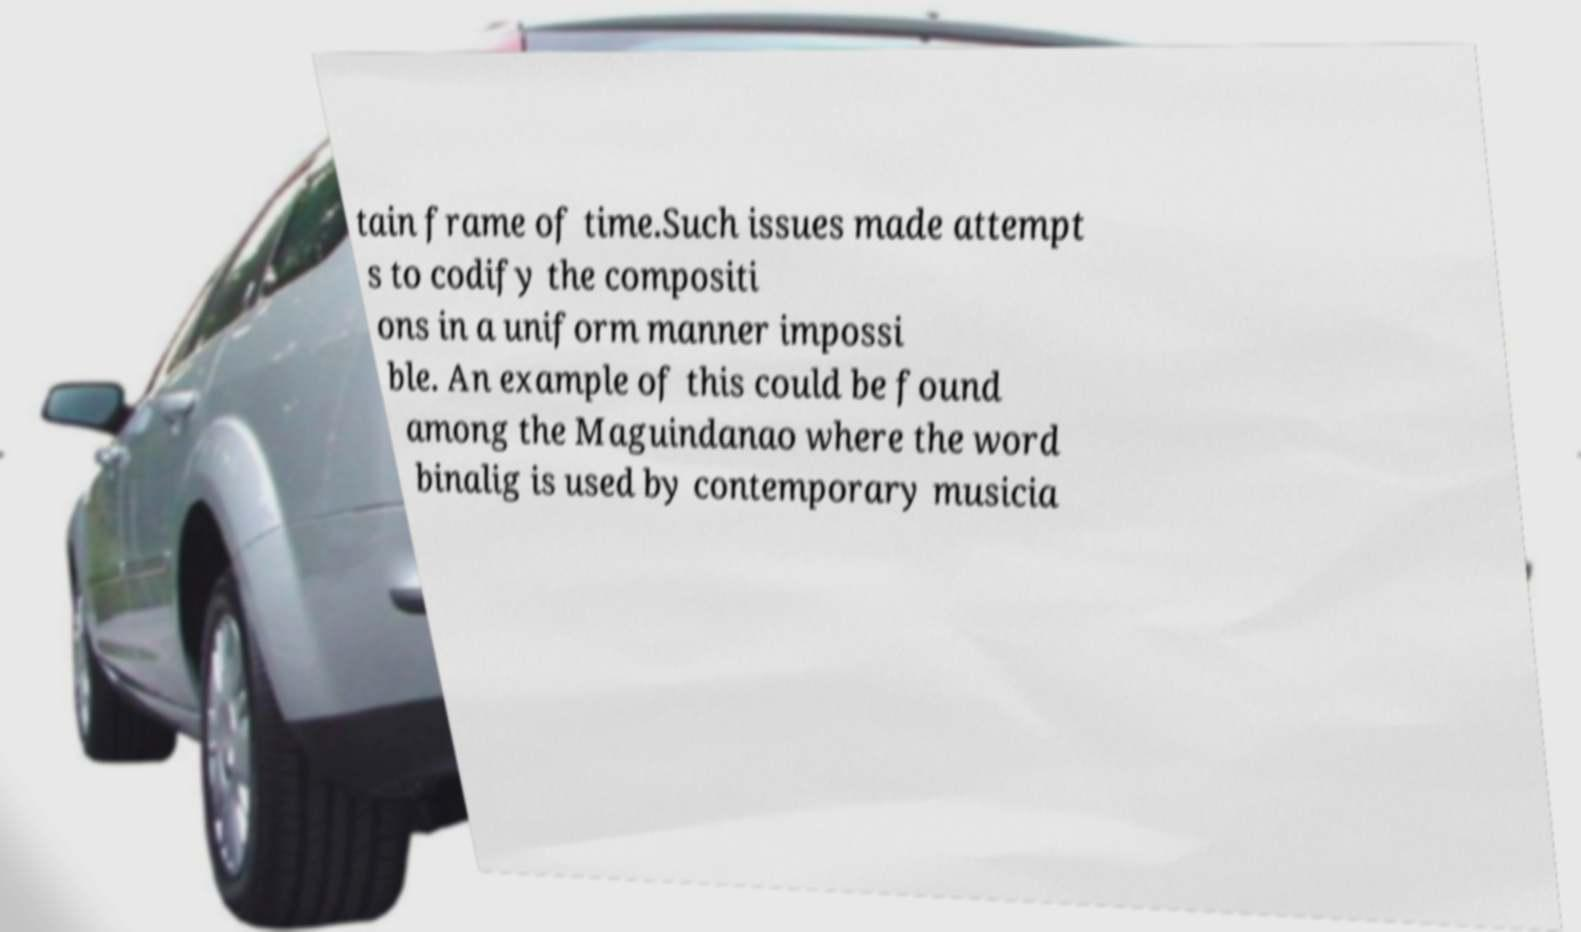Could you assist in decoding the text presented in this image and type it out clearly? tain frame of time.Such issues made attempt s to codify the compositi ons in a uniform manner impossi ble. An example of this could be found among the Maguindanao where the word binalig is used by contemporary musicia 